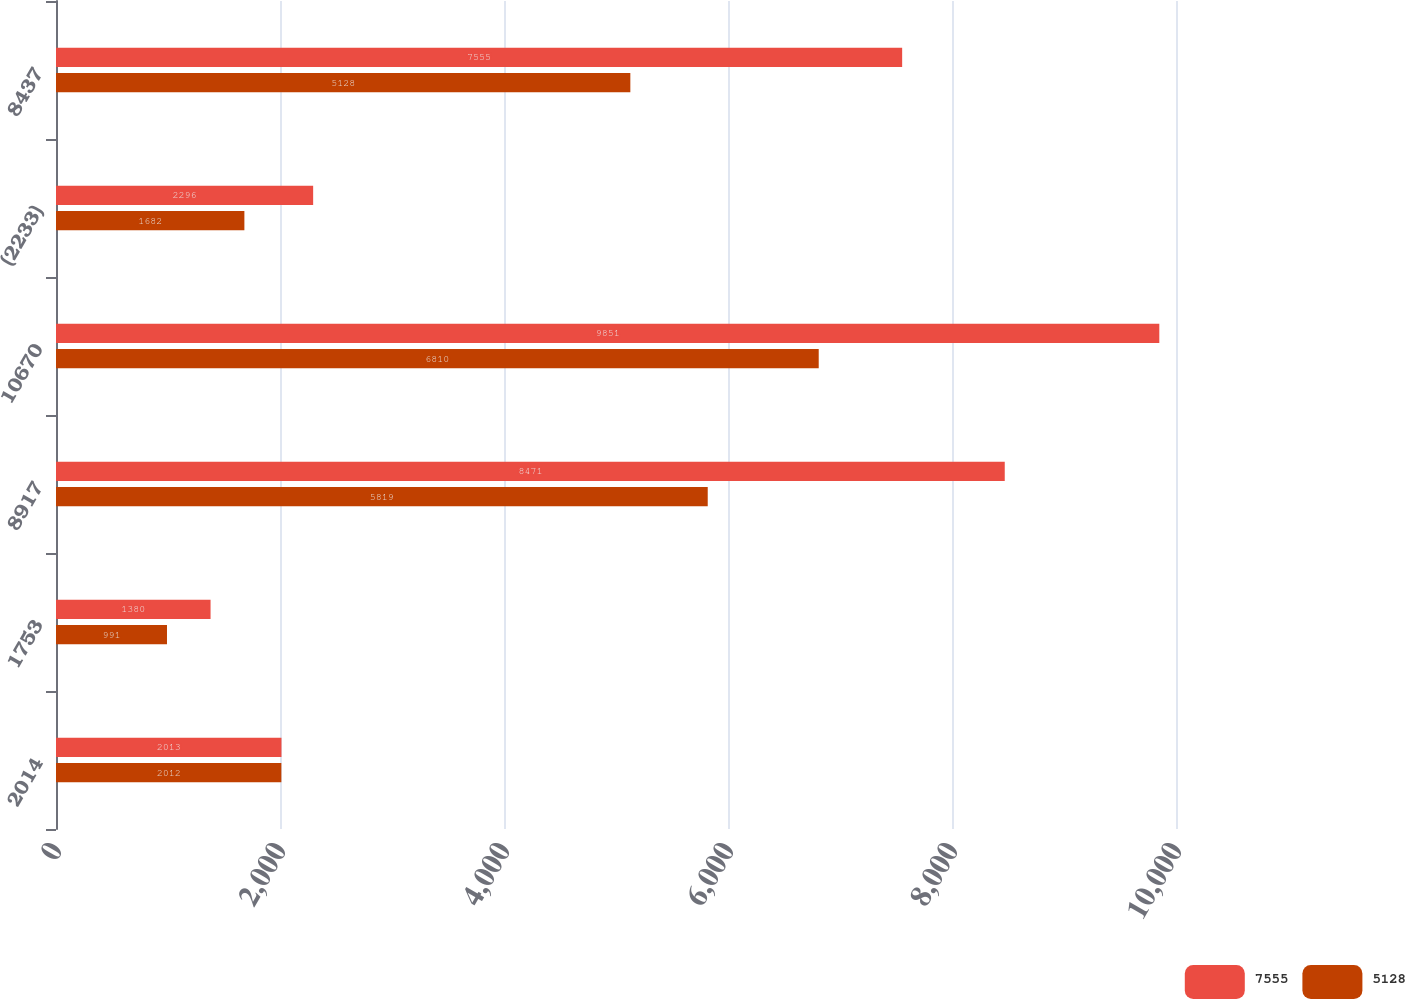Convert chart. <chart><loc_0><loc_0><loc_500><loc_500><stacked_bar_chart><ecel><fcel>2014<fcel>1753<fcel>8917<fcel>10670<fcel>(2233)<fcel>8437<nl><fcel>7555<fcel>2013<fcel>1380<fcel>8471<fcel>9851<fcel>2296<fcel>7555<nl><fcel>5128<fcel>2012<fcel>991<fcel>5819<fcel>6810<fcel>1682<fcel>5128<nl></chart> 